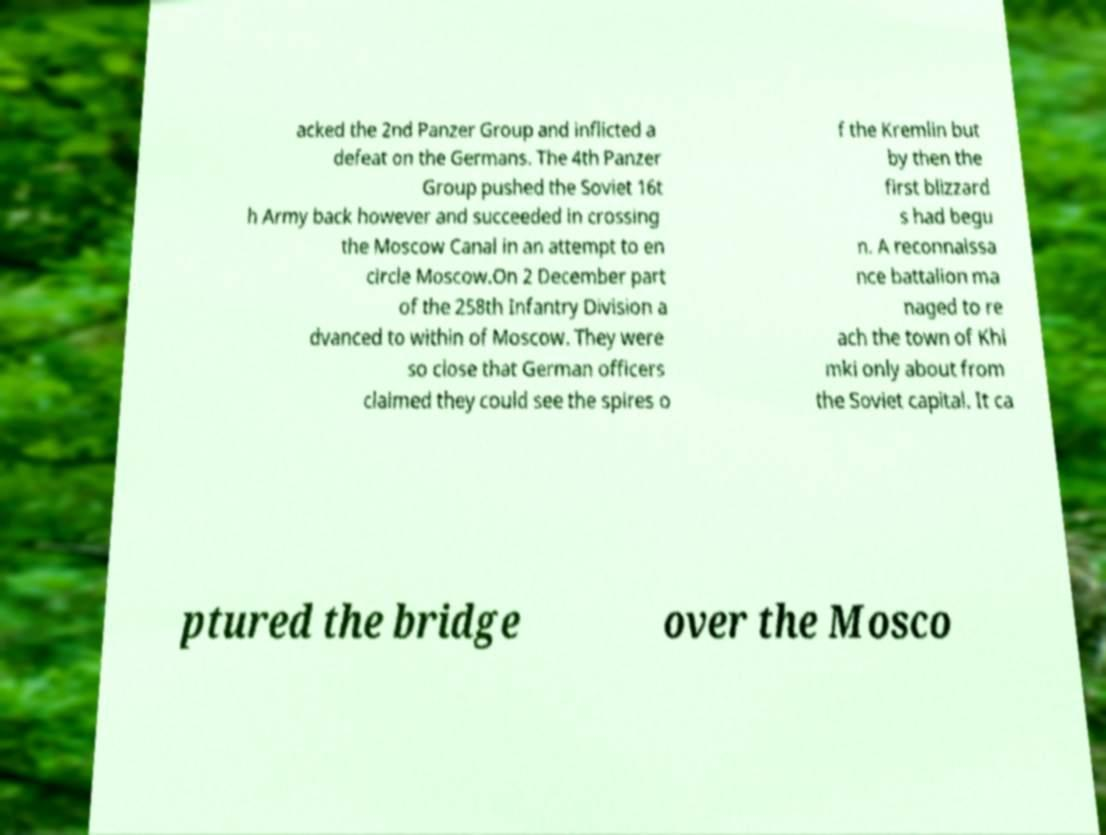I need the written content from this picture converted into text. Can you do that? acked the 2nd Panzer Group and inflicted a defeat on the Germans. The 4th Panzer Group pushed the Soviet 16t h Army back however and succeeded in crossing the Moscow Canal in an attempt to en circle Moscow.On 2 December part of the 258th Infantry Division a dvanced to within of Moscow. They were so close that German officers claimed they could see the spires o f the Kremlin but by then the first blizzard s had begu n. A reconnaissa nce battalion ma naged to re ach the town of Khi mki only about from the Soviet capital. It ca ptured the bridge over the Mosco 